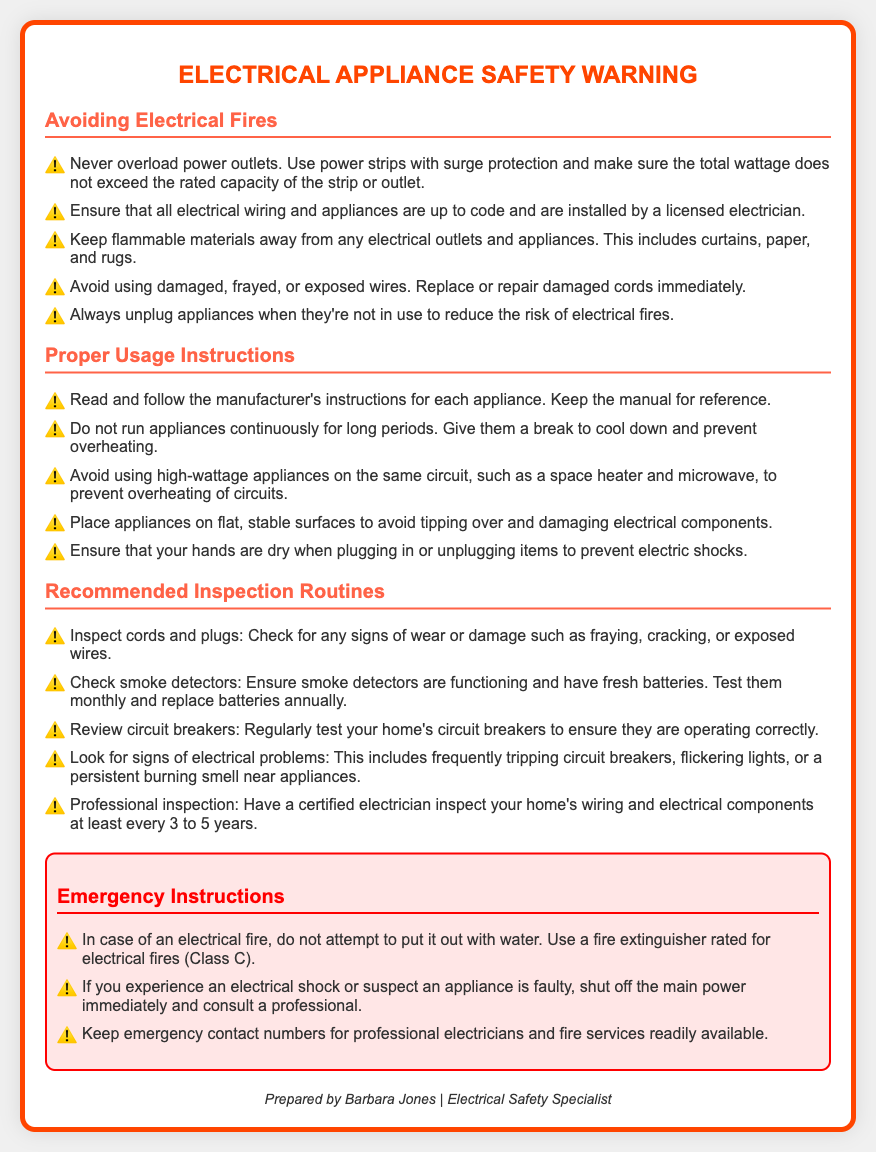what should you never do with power outlets? The document states that you should never overload power outlets.
Answer: never overload power outlets what type of fire extinguisher should be used for electrical fires? The document specifies that you should use a fire extinguisher rated for electrical fires, specifically Class C.
Answer: Class C how often should smoke detectors be tested? According to the document, smoke detectors should be tested monthly.
Answer: monthly what is a key reason to unplug appliances? The document mentions that you should unplug appliances when they're not in use to reduce the risk of electrical fires.
Answer: reduce the risk of electrical fires what is recommended for inspecting cords and plugs? The document advises checking for any signs of wear or damage such as fraying or exposed wires.
Answer: check for any signs of wear or damage why is it important to keep hands dry when handling electrical appliances? The document indicates that keeping hands dry helps prevent electric shocks when plugging in or unplugging items.
Answer: prevent electric shocks how often should a professional inspection of wiring be conducted? The document recommends having a certified electrician inspect your home's wiring at least every 3 to 5 years.
Answer: every 3 to 5 years what should be done if an appliance is suspected to be faulty? The document states that if you suspect an appliance is faulty, you should shut off the main power immediately and consult a professional.
Answer: shut off the main power immediately and consult a professional what should you avoid using on the same circuit? The document advises avoiding using high-wattage appliances on the same circuit to prevent overheating.
Answer: high-wattage appliances 